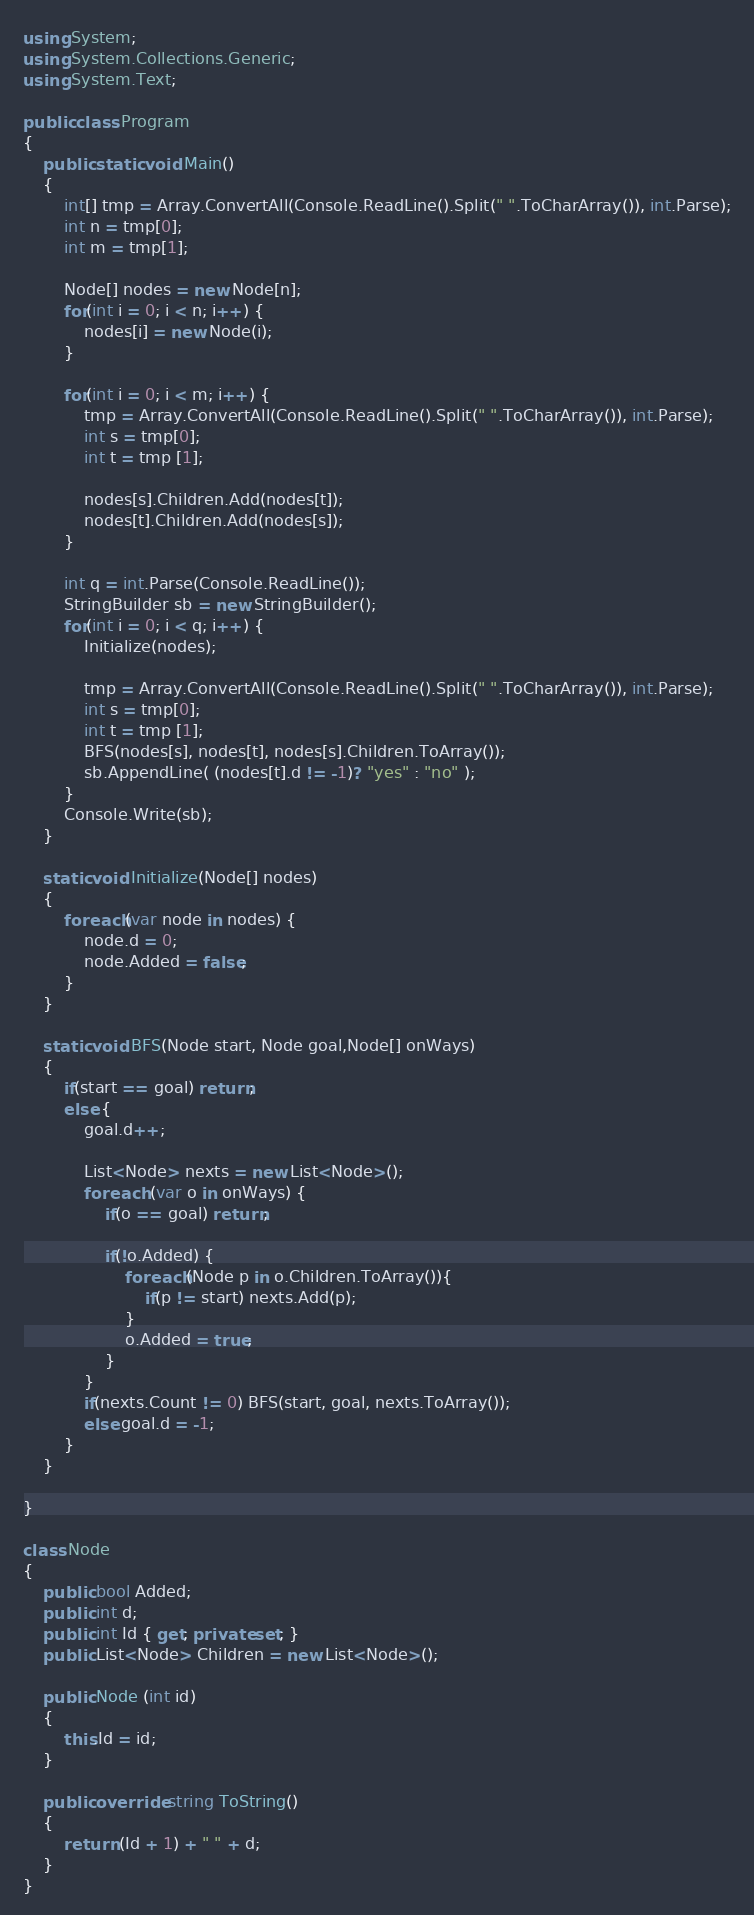Convert code to text. <code><loc_0><loc_0><loc_500><loc_500><_C#_>using System;
using System.Collections.Generic;
using System.Text;
					
public class Program
{	
	public static void Main()
	{
		int[] tmp = Array.ConvertAll(Console.ReadLine().Split(" ".ToCharArray()), int.Parse);
		int n = tmp[0];
		int m = tmp[1];
		
		Node[] nodes = new Node[n];
		for(int i = 0; i < n; i++) {
			nodes[i] = new Node(i);
		}
		
		for(int i = 0; i < m; i++) {
			tmp = Array.ConvertAll(Console.ReadLine().Split(" ".ToCharArray()), int.Parse);
			int s = tmp[0];
			int t = tmp [1];
			
			nodes[s].Children.Add(nodes[t]);
			nodes[t].Children.Add(nodes[s]);
		}
		
		int q = int.Parse(Console.ReadLine());
		StringBuilder sb = new StringBuilder();
		for(int i = 0; i < q; i++) {
			Initialize(nodes);
			
			tmp = Array.ConvertAll(Console.ReadLine().Split(" ".ToCharArray()), int.Parse);
			int s = tmp[0];
			int t = tmp [1];
			BFS(nodes[s], nodes[t], nodes[s].Children.ToArray());
			sb.AppendLine( (nodes[t].d != -1)? "yes" : "no" );
		}
		Console.Write(sb);
	}
	
	static void Initialize(Node[] nodes)
	{
		foreach(var node in nodes) {
			node.d = 0;
			node.Added = false;
		}
	}
	
	static void BFS(Node start, Node goal,Node[] onWays)
	{
		if(start == goal) return;
		else {
			goal.d++;
 
			List<Node> nexts = new List<Node>();
			foreach (var o in onWays) {
				if(o == goal) return;
 
				if(!o.Added) {
					foreach(Node p in o.Children.ToArray()){
						if(p != start) nexts.Add(p);
					}
					o.Added = true;
				}
			}
			if(nexts.Count != 0) BFS(start, goal, nexts.ToArray());
			else goal.d = -1;
		}
	}
	
}

class Node
{
	public bool Added;
	public int d;
	public int Id { get; private set; }
	public List<Node> Children = new List<Node>();
	
	public Node (int id)
	{
		this.Id = id;
	}
	
	public override string ToString()
	{
		return (Id + 1) + " " + d;
	}
}</code> 